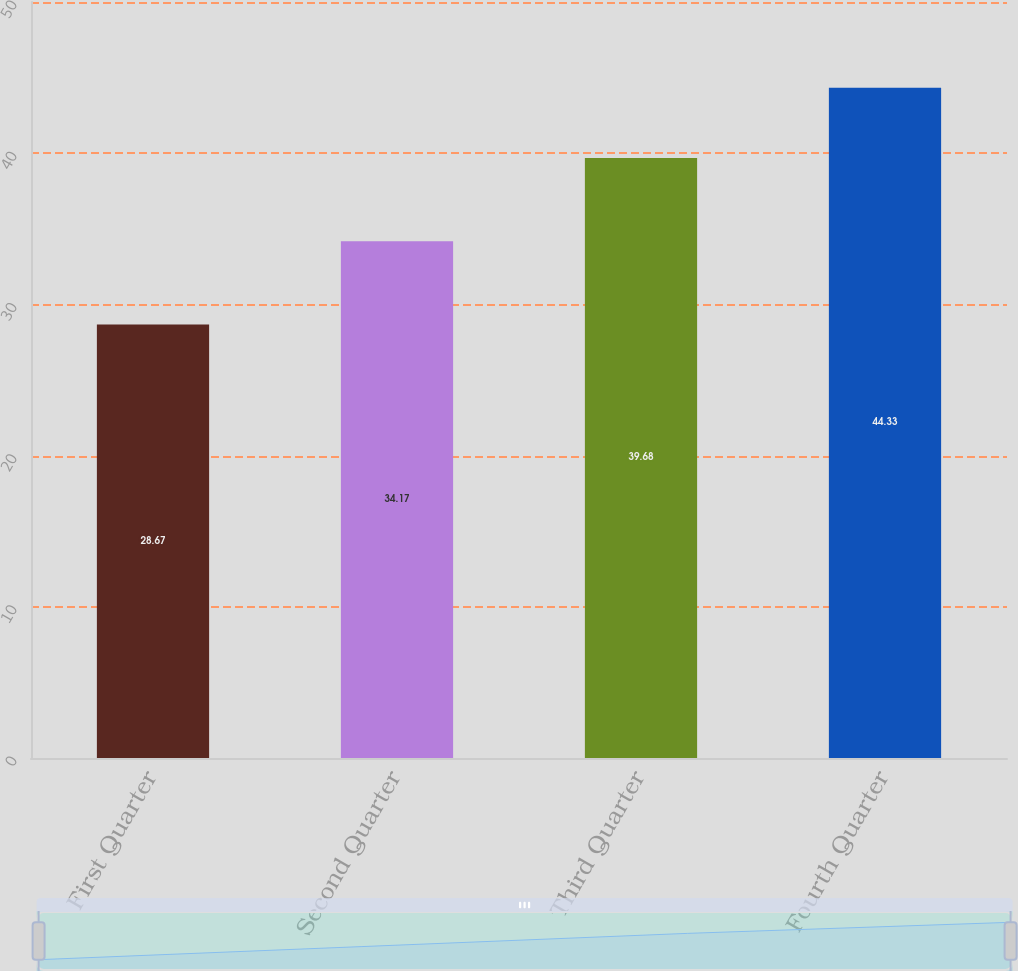Convert chart. <chart><loc_0><loc_0><loc_500><loc_500><bar_chart><fcel>First Quarter<fcel>Second Quarter<fcel>Third Quarter<fcel>Fourth Quarter<nl><fcel>28.67<fcel>34.17<fcel>39.68<fcel>44.33<nl></chart> 